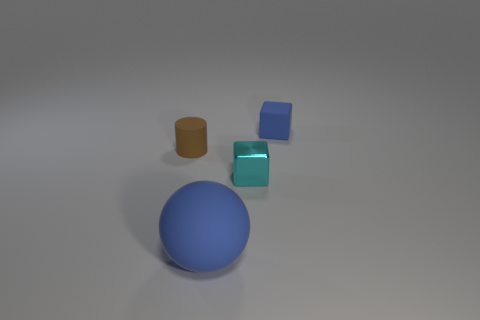Can you tell me the colors and shapes of the objects in the image? Certainly! There is a large blue sphere, a small orange cylinder, a small brown cube, and a tiny shiny cyan cube in the image. 